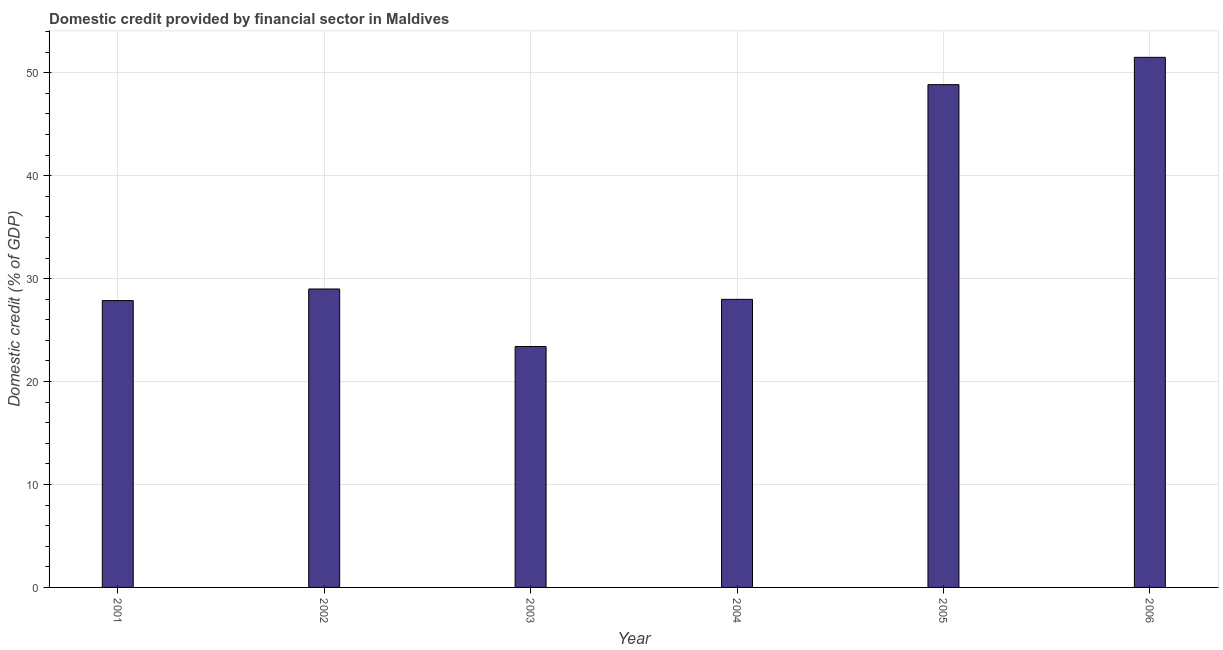Does the graph contain any zero values?
Your response must be concise. No. What is the title of the graph?
Offer a very short reply. Domestic credit provided by financial sector in Maldives. What is the label or title of the X-axis?
Your answer should be compact. Year. What is the label or title of the Y-axis?
Ensure brevity in your answer.  Domestic credit (% of GDP). What is the domestic credit provided by financial sector in 2003?
Your response must be concise. 23.41. Across all years, what is the maximum domestic credit provided by financial sector?
Make the answer very short. 51.5. Across all years, what is the minimum domestic credit provided by financial sector?
Ensure brevity in your answer.  23.41. In which year was the domestic credit provided by financial sector minimum?
Keep it short and to the point. 2003. What is the sum of the domestic credit provided by financial sector?
Make the answer very short. 208.62. What is the difference between the domestic credit provided by financial sector in 2005 and 2006?
Your response must be concise. -2.66. What is the average domestic credit provided by financial sector per year?
Offer a terse response. 34.77. What is the median domestic credit provided by financial sector?
Your response must be concise. 28.49. What is the difference between the highest and the second highest domestic credit provided by financial sector?
Your answer should be compact. 2.66. Is the sum of the domestic credit provided by financial sector in 2002 and 2003 greater than the maximum domestic credit provided by financial sector across all years?
Offer a terse response. Yes. What is the difference between the highest and the lowest domestic credit provided by financial sector?
Provide a succinct answer. 28.1. How many bars are there?
Your response must be concise. 6. What is the Domestic credit (% of GDP) in 2001?
Provide a succinct answer. 27.87. What is the Domestic credit (% of GDP) in 2002?
Offer a terse response. 29. What is the Domestic credit (% of GDP) in 2003?
Provide a succinct answer. 23.41. What is the Domestic credit (% of GDP) in 2004?
Ensure brevity in your answer.  27.99. What is the Domestic credit (% of GDP) of 2005?
Your answer should be compact. 48.85. What is the Domestic credit (% of GDP) in 2006?
Ensure brevity in your answer.  51.5. What is the difference between the Domestic credit (% of GDP) in 2001 and 2002?
Offer a terse response. -1.13. What is the difference between the Domestic credit (% of GDP) in 2001 and 2003?
Provide a succinct answer. 4.46. What is the difference between the Domestic credit (% of GDP) in 2001 and 2004?
Keep it short and to the point. -0.12. What is the difference between the Domestic credit (% of GDP) in 2001 and 2005?
Give a very brief answer. -20.98. What is the difference between the Domestic credit (% of GDP) in 2001 and 2006?
Provide a short and direct response. -23.63. What is the difference between the Domestic credit (% of GDP) in 2002 and 2003?
Ensure brevity in your answer.  5.59. What is the difference between the Domestic credit (% of GDP) in 2002 and 2005?
Offer a terse response. -19.85. What is the difference between the Domestic credit (% of GDP) in 2002 and 2006?
Provide a succinct answer. -22.51. What is the difference between the Domestic credit (% of GDP) in 2003 and 2004?
Give a very brief answer. -4.58. What is the difference between the Domestic credit (% of GDP) in 2003 and 2005?
Your response must be concise. -25.44. What is the difference between the Domestic credit (% of GDP) in 2003 and 2006?
Make the answer very short. -28.1. What is the difference between the Domestic credit (% of GDP) in 2004 and 2005?
Your response must be concise. -20.86. What is the difference between the Domestic credit (% of GDP) in 2004 and 2006?
Your answer should be compact. -23.52. What is the difference between the Domestic credit (% of GDP) in 2005 and 2006?
Keep it short and to the point. -2.66. What is the ratio of the Domestic credit (% of GDP) in 2001 to that in 2002?
Provide a succinct answer. 0.96. What is the ratio of the Domestic credit (% of GDP) in 2001 to that in 2003?
Your answer should be very brief. 1.19. What is the ratio of the Domestic credit (% of GDP) in 2001 to that in 2005?
Offer a terse response. 0.57. What is the ratio of the Domestic credit (% of GDP) in 2001 to that in 2006?
Provide a succinct answer. 0.54. What is the ratio of the Domestic credit (% of GDP) in 2002 to that in 2003?
Offer a very short reply. 1.24. What is the ratio of the Domestic credit (% of GDP) in 2002 to that in 2004?
Your answer should be compact. 1.04. What is the ratio of the Domestic credit (% of GDP) in 2002 to that in 2005?
Keep it short and to the point. 0.59. What is the ratio of the Domestic credit (% of GDP) in 2002 to that in 2006?
Provide a succinct answer. 0.56. What is the ratio of the Domestic credit (% of GDP) in 2003 to that in 2004?
Ensure brevity in your answer.  0.84. What is the ratio of the Domestic credit (% of GDP) in 2003 to that in 2005?
Provide a short and direct response. 0.48. What is the ratio of the Domestic credit (% of GDP) in 2003 to that in 2006?
Make the answer very short. 0.45. What is the ratio of the Domestic credit (% of GDP) in 2004 to that in 2005?
Your answer should be compact. 0.57. What is the ratio of the Domestic credit (% of GDP) in 2004 to that in 2006?
Make the answer very short. 0.54. What is the ratio of the Domestic credit (% of GDP) in 2005 to that in 2006?
Your answer should be very brief. 0.95. 